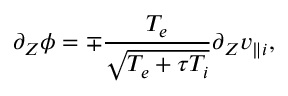Convert formula to latex. <formula><loc_0><loc_0><loc_500><loc_500>\partial _ { Z } \phi = \mp \frac { T _ { e } } { \sqrt { T _ { e } + \tau T _ { i } } } \partial _ { Z } v _ { \| i } ,</formula> 